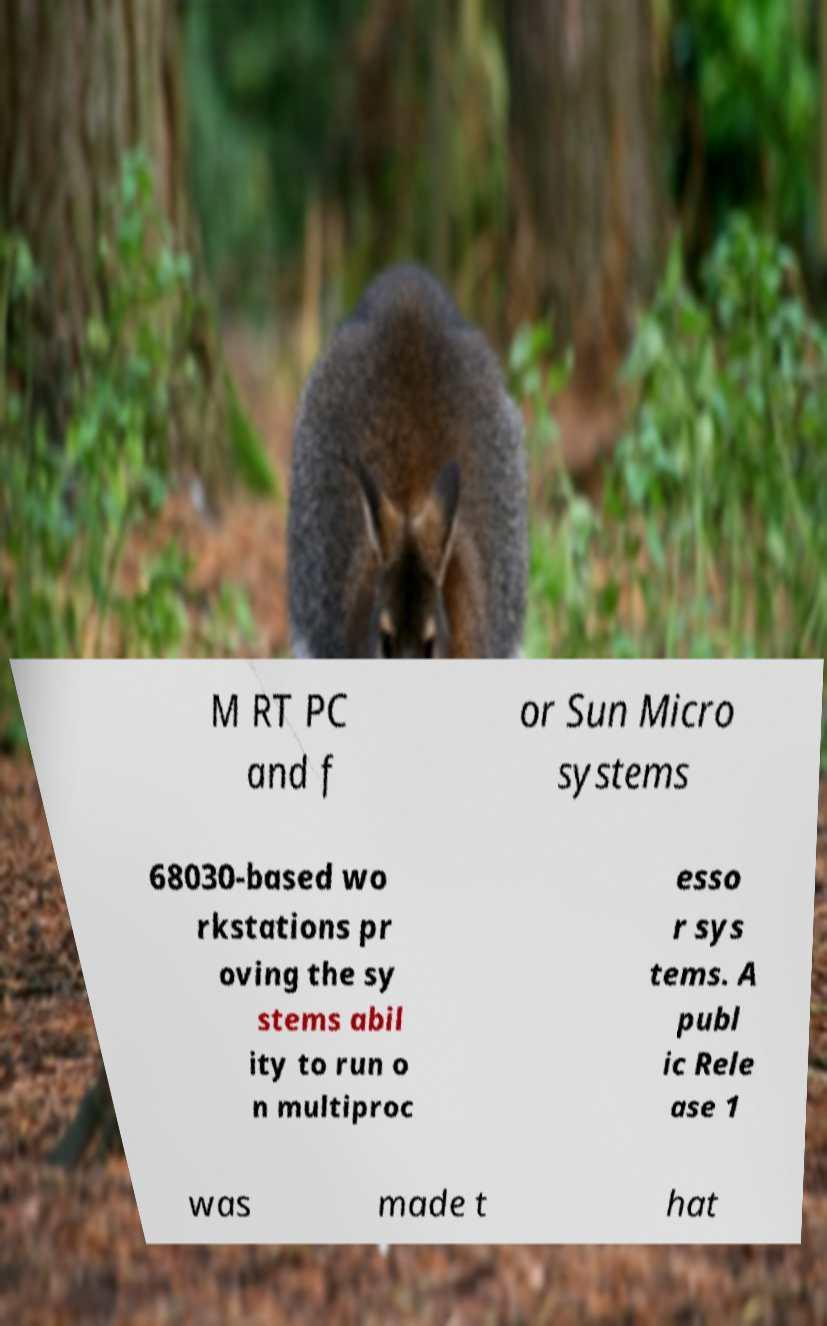Can you accurately transcribe the text from the provided image for me? M RT PC and f or Sun Micro systems 68030-based wo rkstations pr oving the sy stems abil ity to run o n multiproc esso r sys tems. A publ ic Rele ase 1 was made t hat 